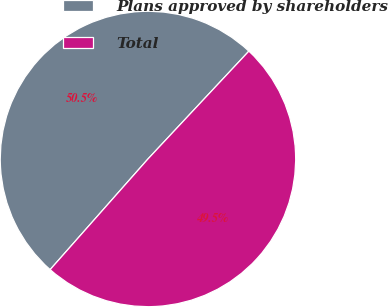<chart> <loc_0><loc_0><loc_500><loc_500><pie_chart><fcel>Plans approved by shareholders<fcel>Total<nl><fcel>50.45%<fcel>49.55%<nl></chart> 